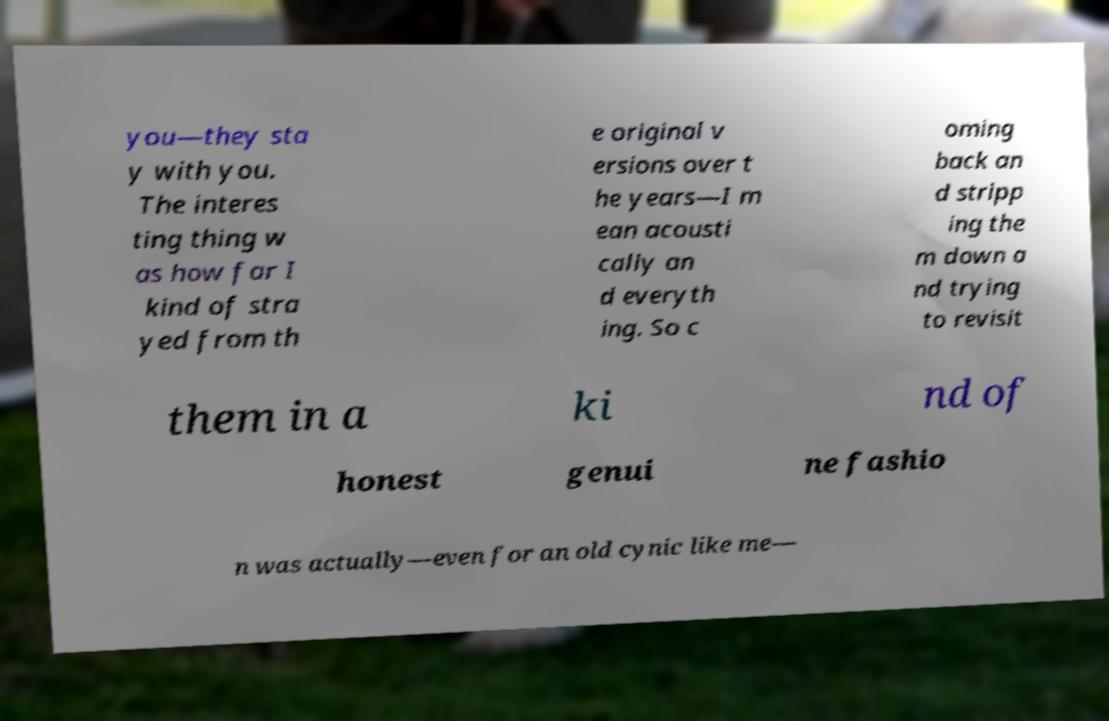Please read and relay the text visible in this image. What does it say? you—they sta y with you. The interes ting thing w as how far I kind of stra yed from th e original v ersions over t he years—I m ean acousti cally an d everyth ing. So c oming back an d stripp ing the m down a nd trying to revisit them in a ki nd of honest genui ne fashio n was actually—even for an old cynic like me— 